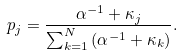Convert formula to latex. <formula><loc_0><loc_0><loc_500><loc_500>p _ { j } = \frac { \alpha ^ { - 1 } + \kappa _ { j } } { \sum _ { k = 1 } ^ { N } { ( \alpha ^ { - 1 } + \kappa _ { k } ) } } .</formula> 